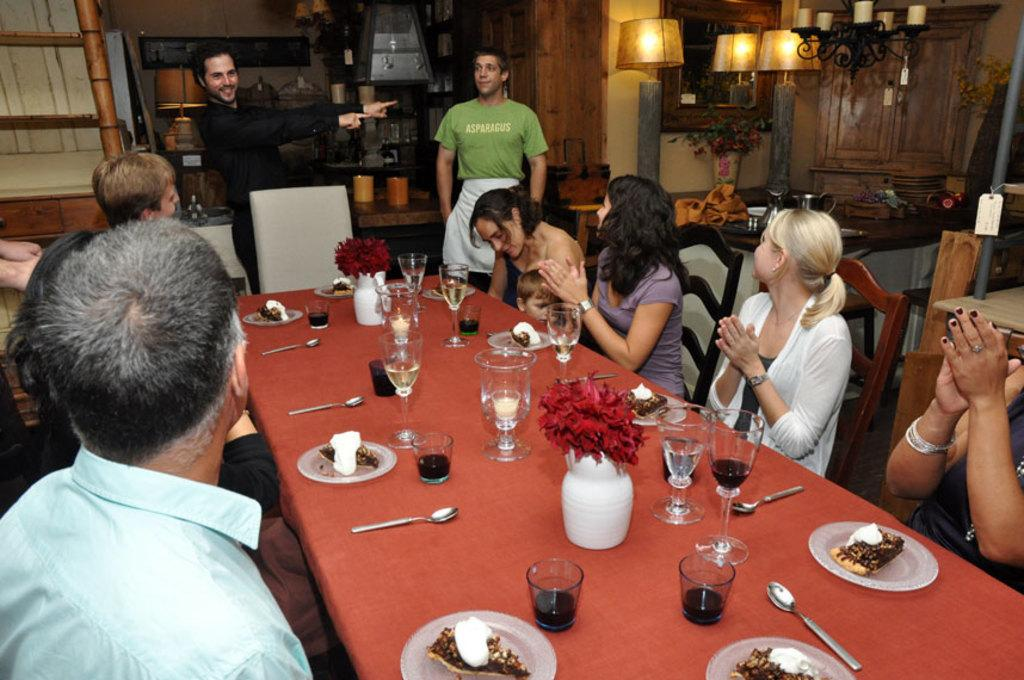What are the people in the image doing? The people in the image are sitting on chairs. What lighting fixtures can be seen in the image? There is a lamp and a chandelier in the image. What piece of furniture is present in the image? There is a table in the image. What items are on the table? There are glasses, plates, spoons, and a flower flask on the table. What is the chance of the floor collapsing in the image? The image does not provide any information about the floor or its structural integrity, so it is impossible to determine the chance of it collapsing. Can you describe how the people in the image are kicking the table? There is no indication in the image that the people are kicking the table; they are simply sitting on chairs. 